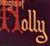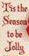Read the text from these images in sequence, separated by a semicolon. Holly; # 